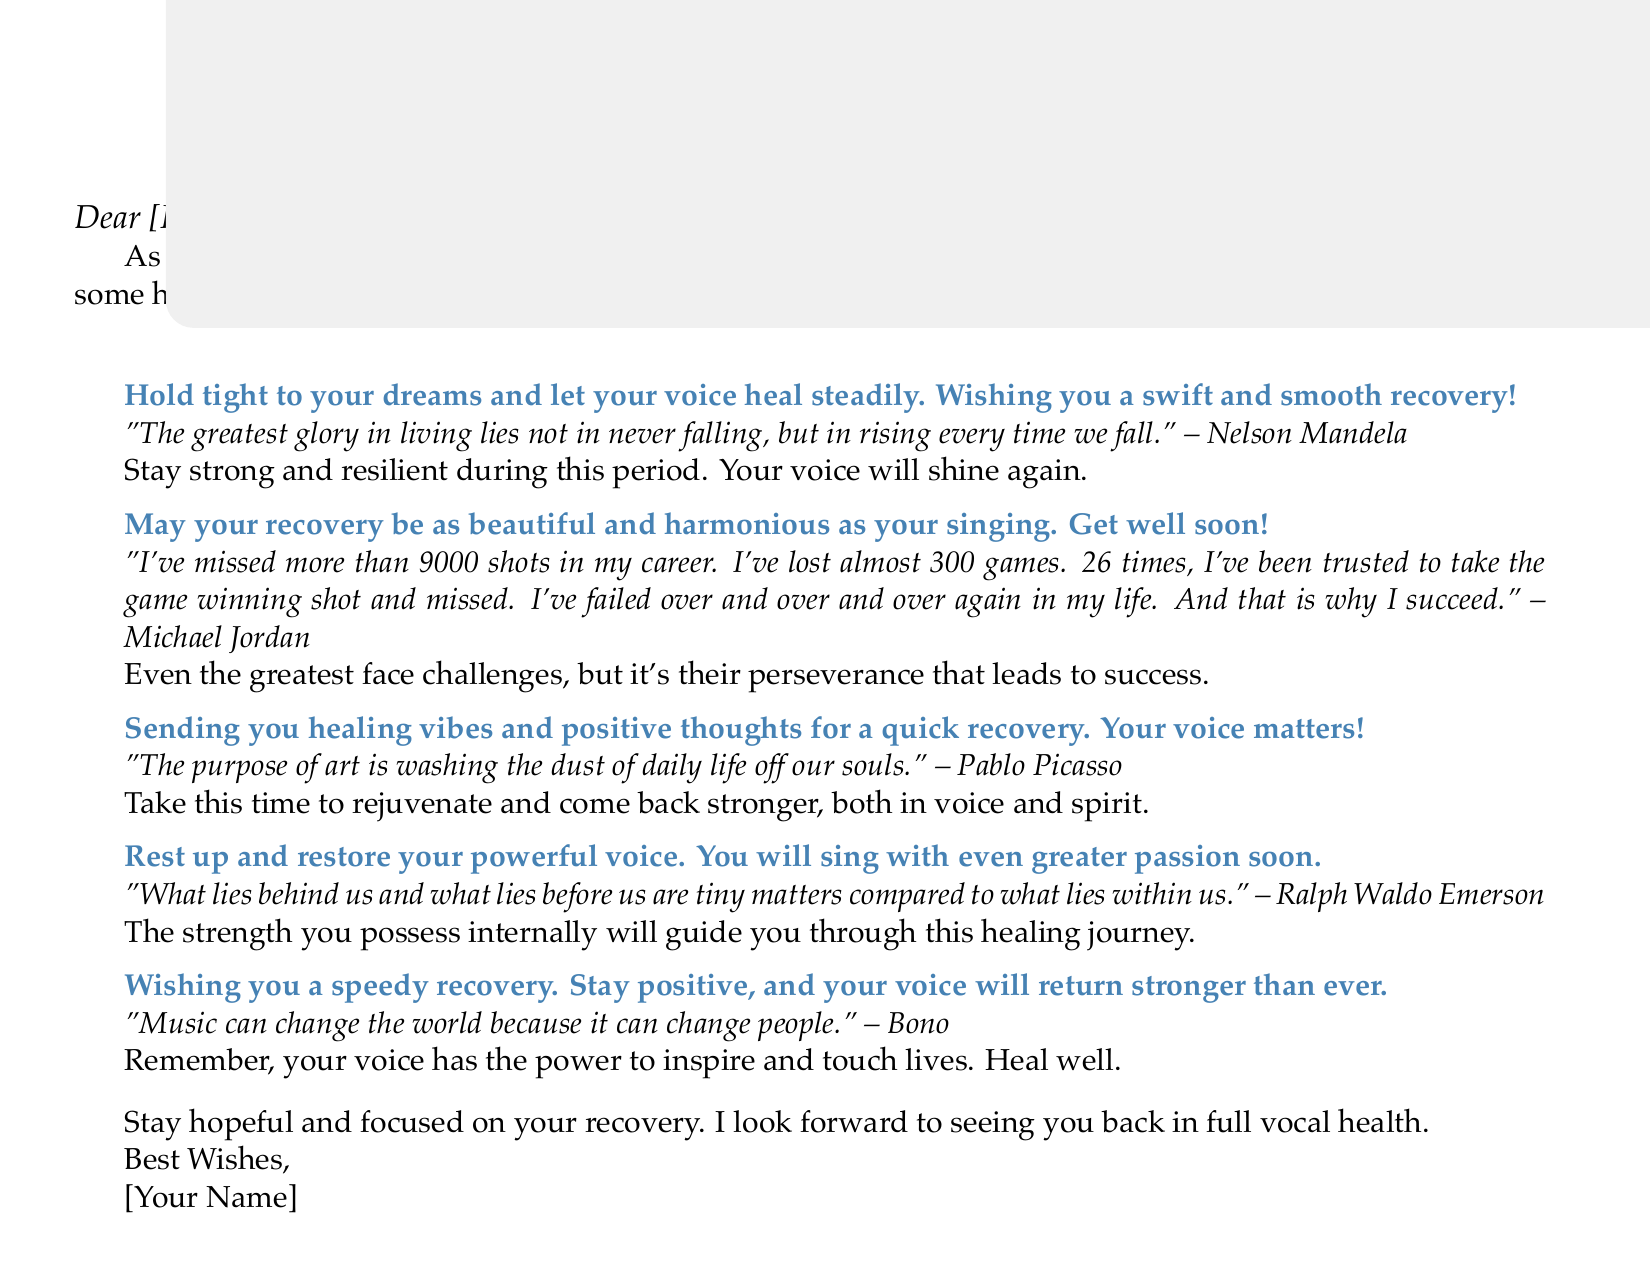What is the title of the card? The title of the card is presented prominently at the top in large text.
Answer: Best Wishes for a Speedy Recovery Who is the card addressed to? The card includes a space to fill in the recipient's name.
Answer: [Patient's Name] What is the color theme of the card? The card uses a specific color for text and background elements, as well as for the quotes.
Answer: Blue Which famous singer is quoted regarding perseverance? The quote refers to a famous sports figure known for perseverance in a different field.
Answer: Michael Jordan What is the message related to healing? The document includes a specific encouragement for the recipient about their recovery.
Answer: Sending you healing vibes and positive thoughts for a quick recovery. Your voice matters! How many quotes are featured in the card? The card presents a collection of inspirational quotes from various authors.
Answer: Five What does the card suggest the recipient should do during recovery? The card emphasizes a particular activity that is crucial for recovery.
Answer: Rest up and restore your powerful voice What overarching theme is present throughout the messages? The card consistently returns to a specific encouraging concept related to health and strength.
Answer: Strength and healing What is the closing message of the card? The card concludes with a general well-wishing note towards the end of the text.
Answer: Best Wishes 